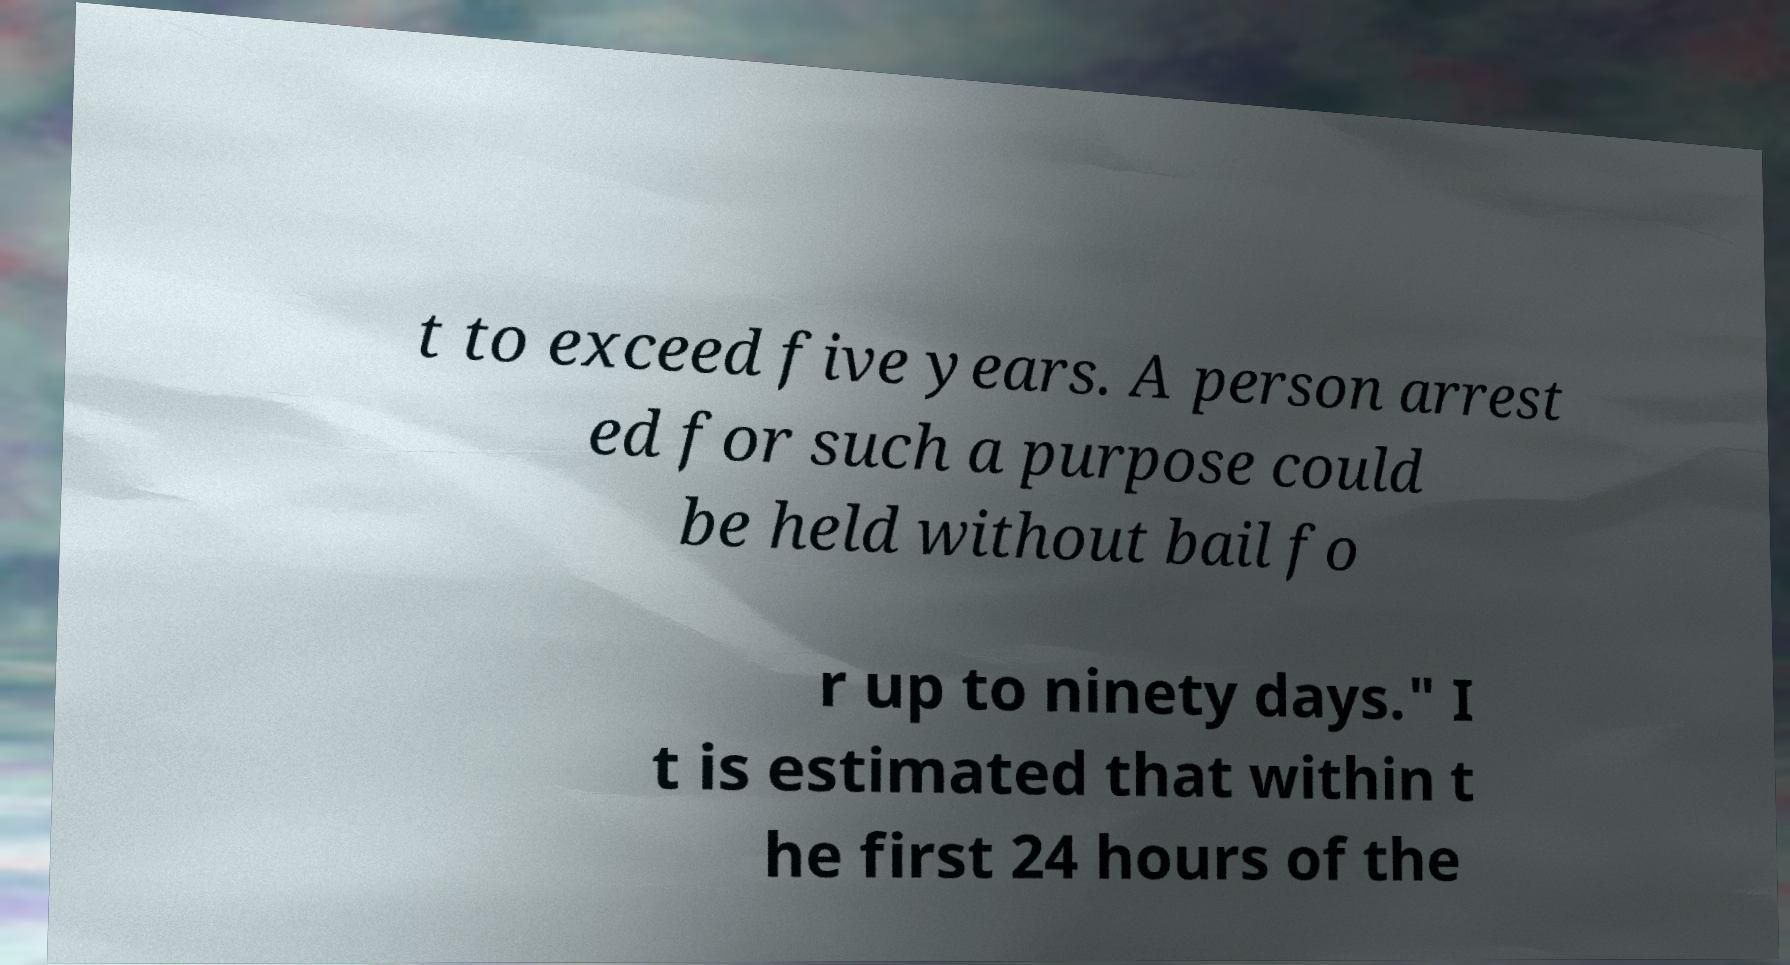What messages or text are displayed in this image? I need them in a readable, typed format. t to exceed five years. A person arrest ed for such a purpose could be held without bail fo r up to ninety days." I t is estimated that within t he first 24 hours of the 